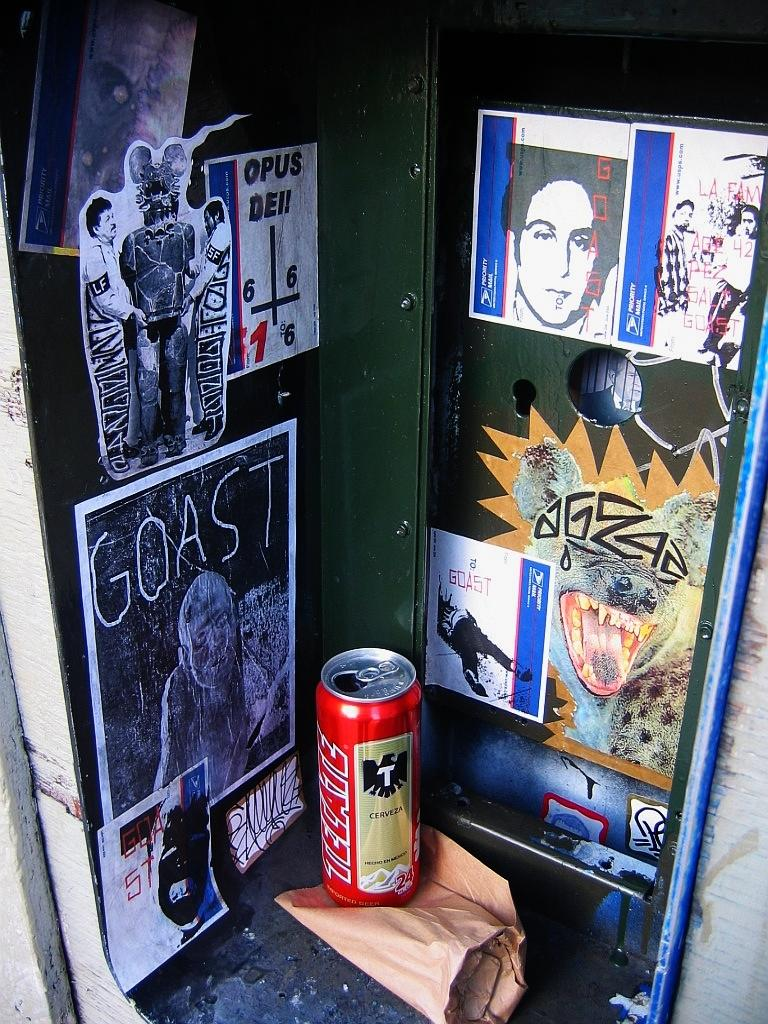<image>
Offer a succinct explanation of the picture presented. the word goast that is next to a can 